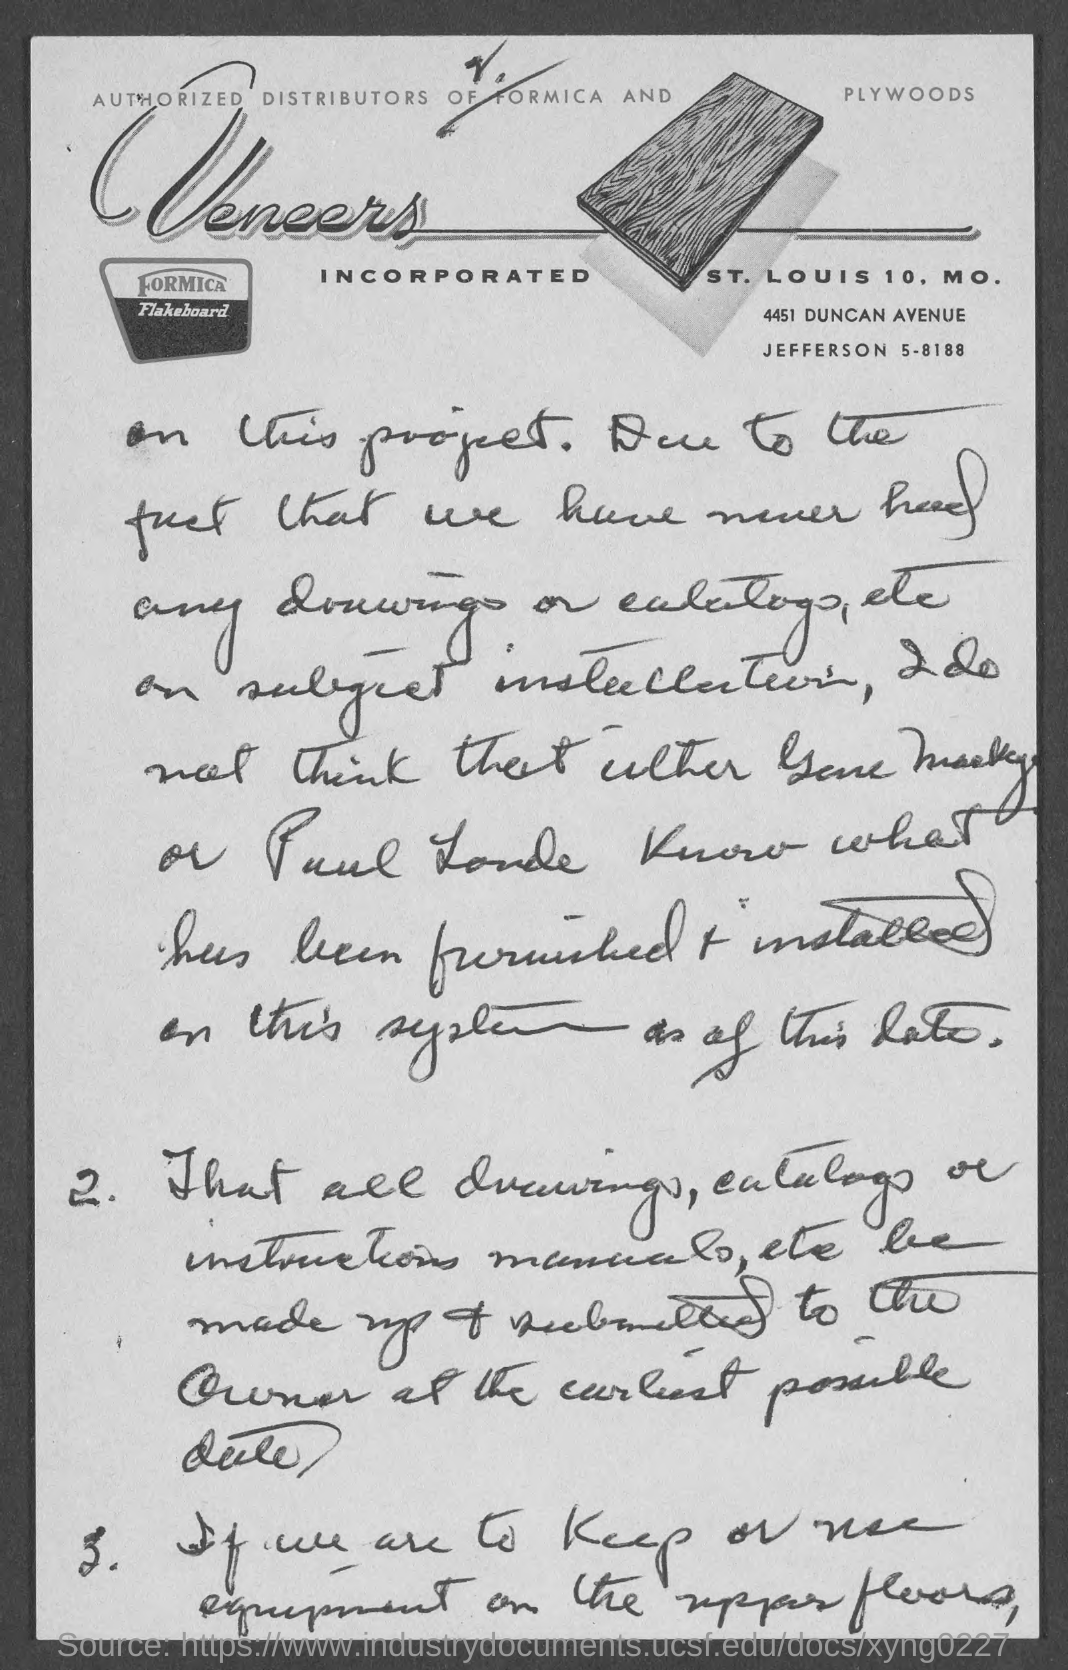Identify some key points in this picture. The firm's name is Veneers. 